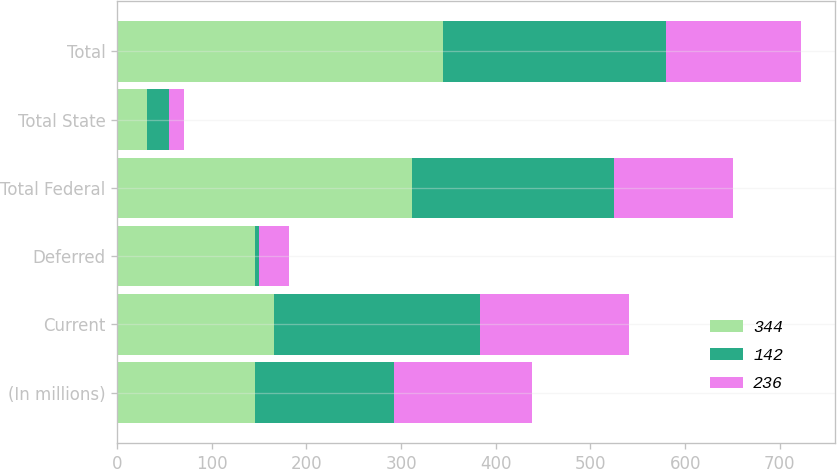Convert chart to OTSL. <chart><loc_0><loc_0><loc_500><loc_500><stacked_bar_chart><ecel><fcel>(In millions)<fcel>Current<fcel>Deferred<fcel>Total Federal<fcel>Total State<fcel>Total<nl><fcel>344<fcel>146<fcel>166<fcel>146<fcel>312<fcel>32<fcel>344<nl><fcel>142<fcel>146<fcel>217<fcel>4<fcel>213<fcel>23<fcel>236<nl><fcel>236<fcel>146<fcel>158<fcel>32<fcel>126<fcel>16<fcel>142<nl></chart> 